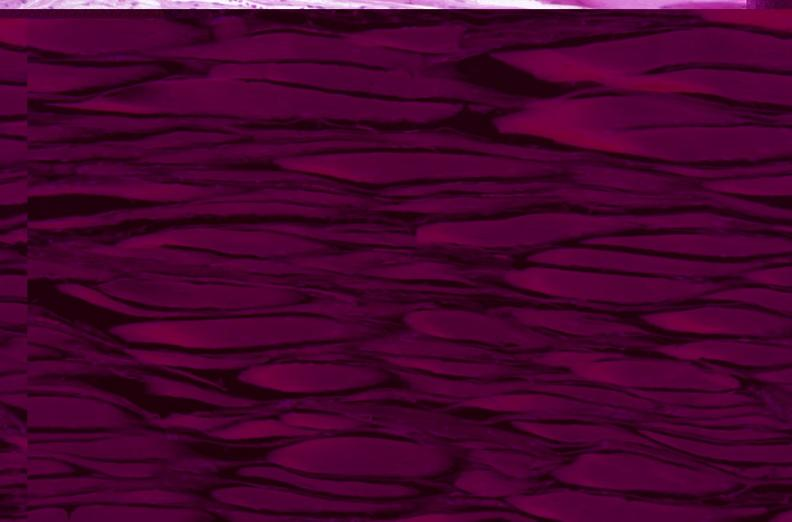s musculoskeletal present?
Answer the question using a single word or phrase. Yes 